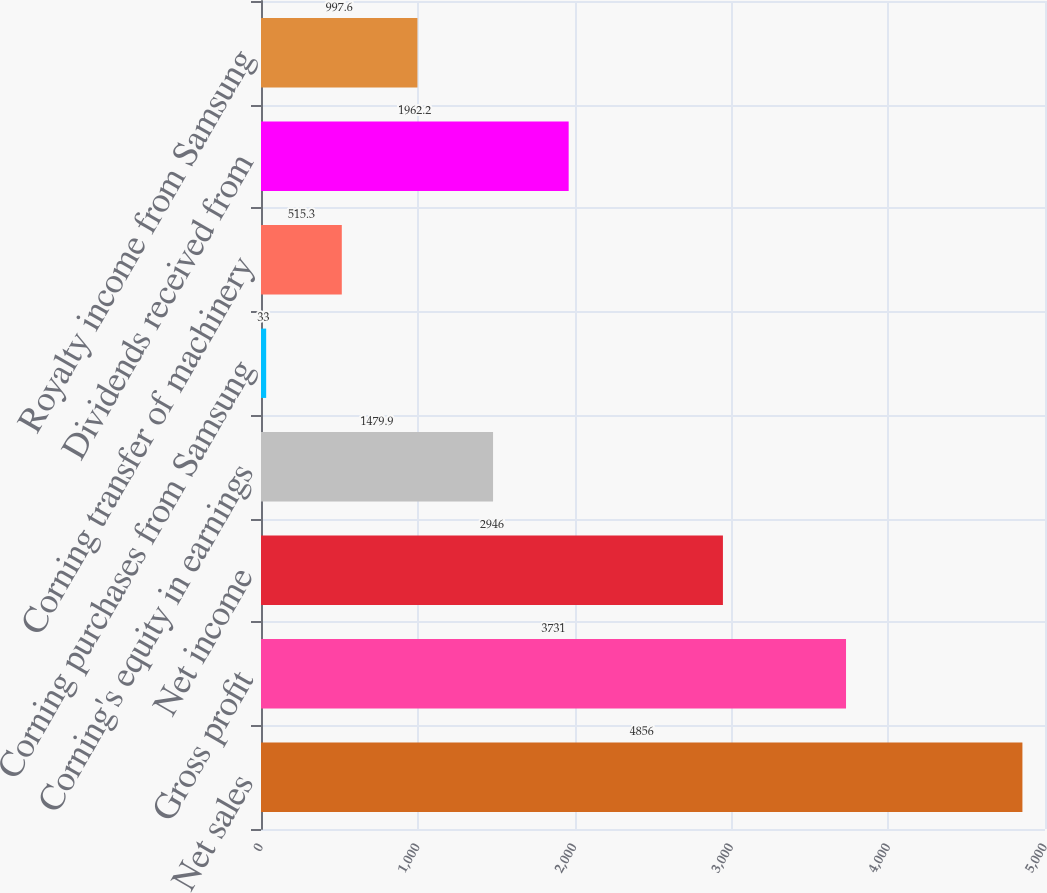<chart> <loc_0><loc_0><loc_500><loc_500><bar_chart><fcel>Net sales<fcel>Gross profit<fcel>Net income<fcel>Corning's equity in earnings<fcel>Corning purchases from Samsung<fcel>Corning transfer of machinery<fcel>Dividends received from<fcel>Royalty income from Samsung<nl><fcel>4856<fcel>3731<fcel>2946<fcel>1479.9<fcel>33<fcel>515.3<fcel>1962.2<fcel>997.6<nl></chart> 